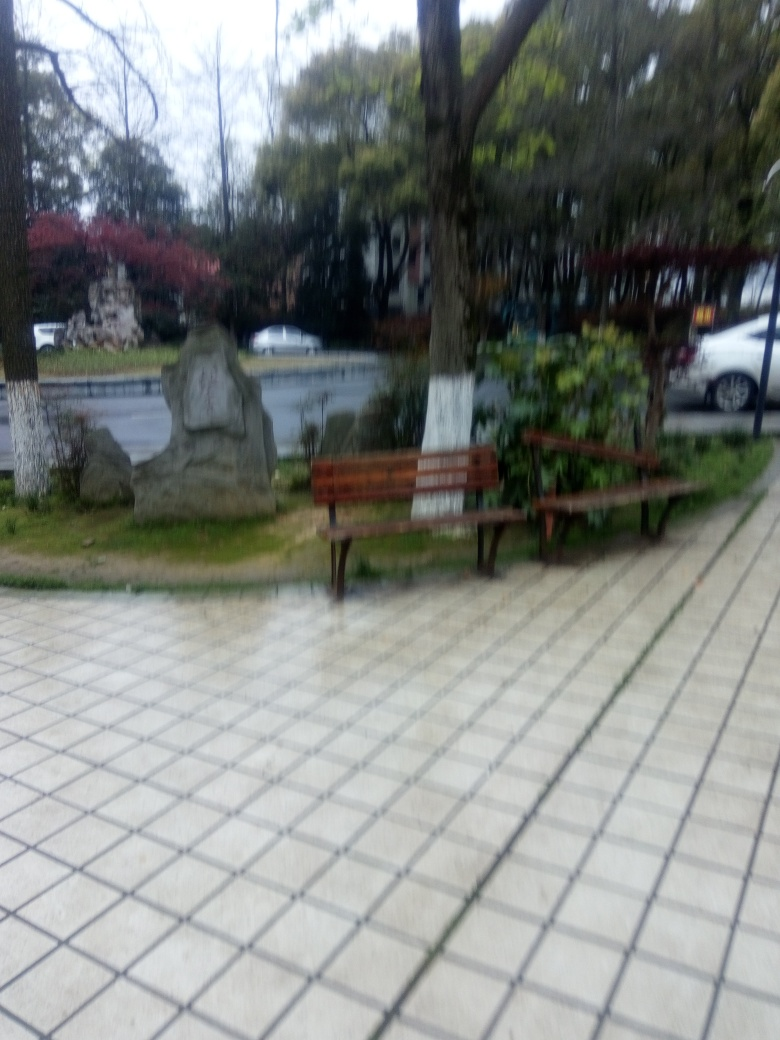What time of year does this image suggest? Given the bare branches on some of the trees and the presence of fallen leaves, it suggests a season like late autumn or early winter. The overcast sky could also indicate transitioning weather, which often accompanies these seasons. 